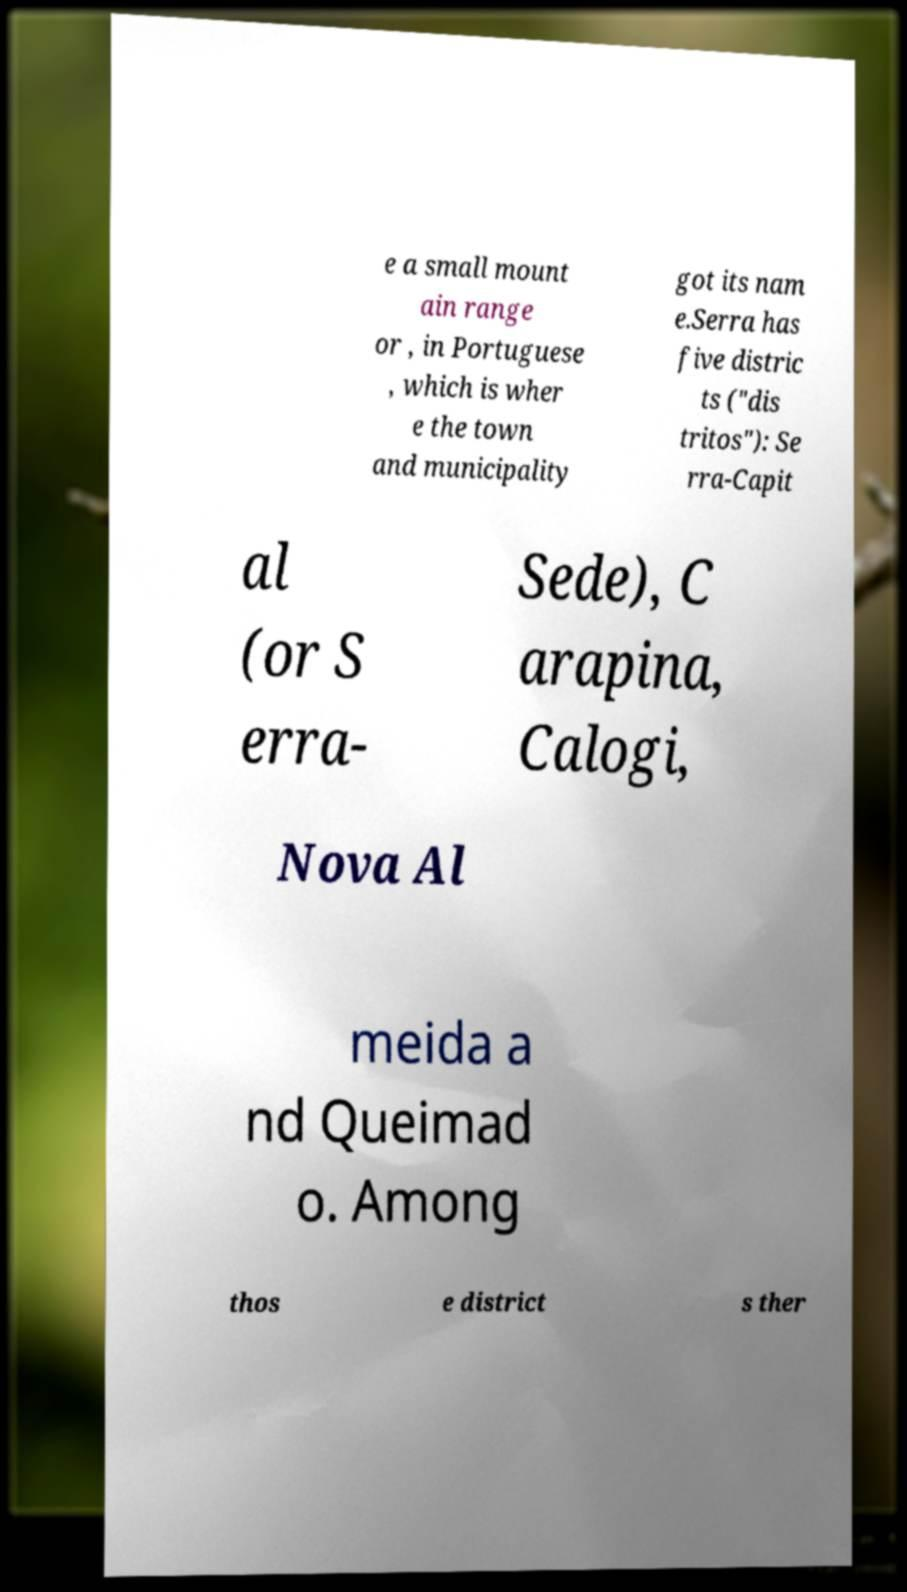I need the written content from this picture converted into text. Can you do that? e a small mount ain range or , in Portuguese , which is wher e the town and municipality got its nam e.Serra has five distric ts ("dis tritos"): Se rra-Capit al (or S erra- Sede), C arapina, Calogi, Nova Al meida a nd Queimad o. Among thos e district s ther 